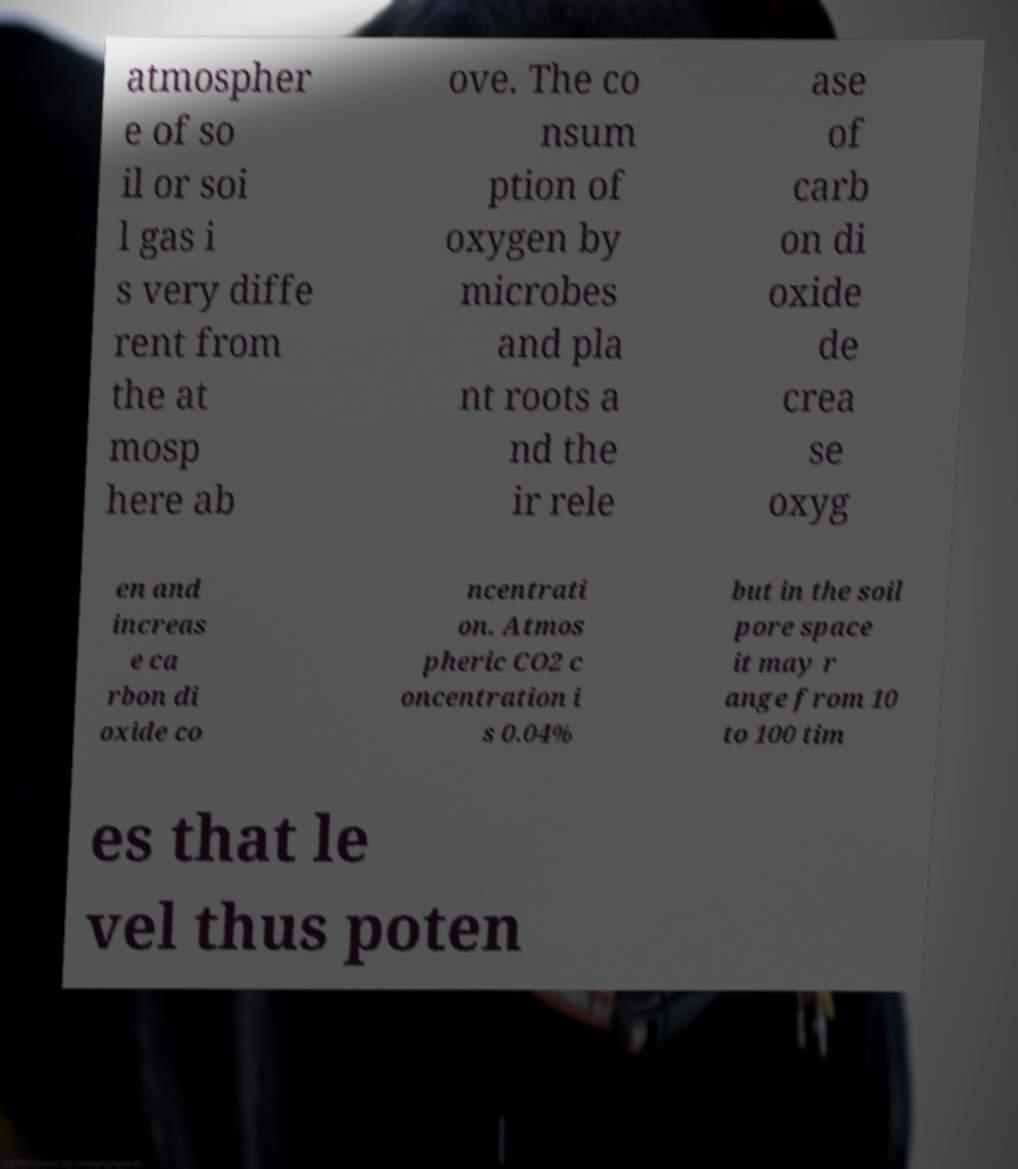Can you accurately transcribe the text from the provided image for me? atmospher e of so il or soi l gas i s very diffe rent from the at mosp here ab ove. The co nsum ption of oxygen by microbes and pla nt roots a nd the ir rele ase of carb on di oxide de crea se oxyg en and increas e ca rbon di oxide co ncentrati on. Atmos pheric CO2 c oncentration i s 0.04% but in the soil pore space it may r ange from 10 to 100 tim es that le vel thus poten 